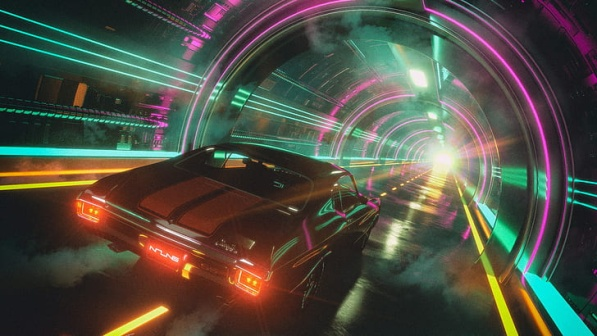Can you describe the main features of this image for me? The image captures a sleek, black sports car speeding through a brightly illuminated tunnel, characterized by its vibrant neon lights in hues of pink and blue, creating a luminescent arch overhead. This setting suggests a dynamic, futuristic world, possibly hinting at advanced technology and urban progression. The car, detailed with glowing red taillights and a reflective body, in the foreground, drives along a road marked with vivid yellow lines. It's moving towards a bright white light at the tunnel's end, which might symbolize an exit or an enticing unknown future. The blurred cityscape in the background with towering structures adds depth, inviting viewers to contemplate the relationship between the car's journey and the urban environment beyond. 